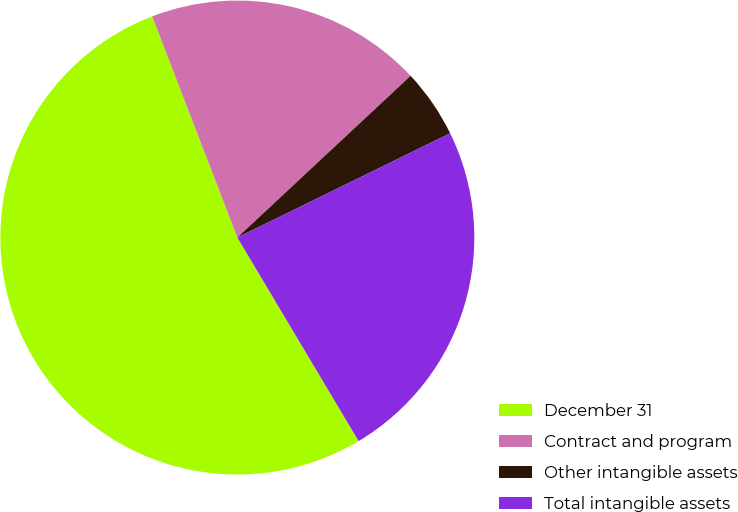<chart> <loc_0><loc_0><loc_500><loc_500><pie_chart><fcel>December 31<fcel>Contract and program<fcel>Other intangible assets<fcel>Total intangible assets<nl><fcel>52.7%<fcel>18.9%<fcel>4.7%<fcel>23.7%<nl></chart> 